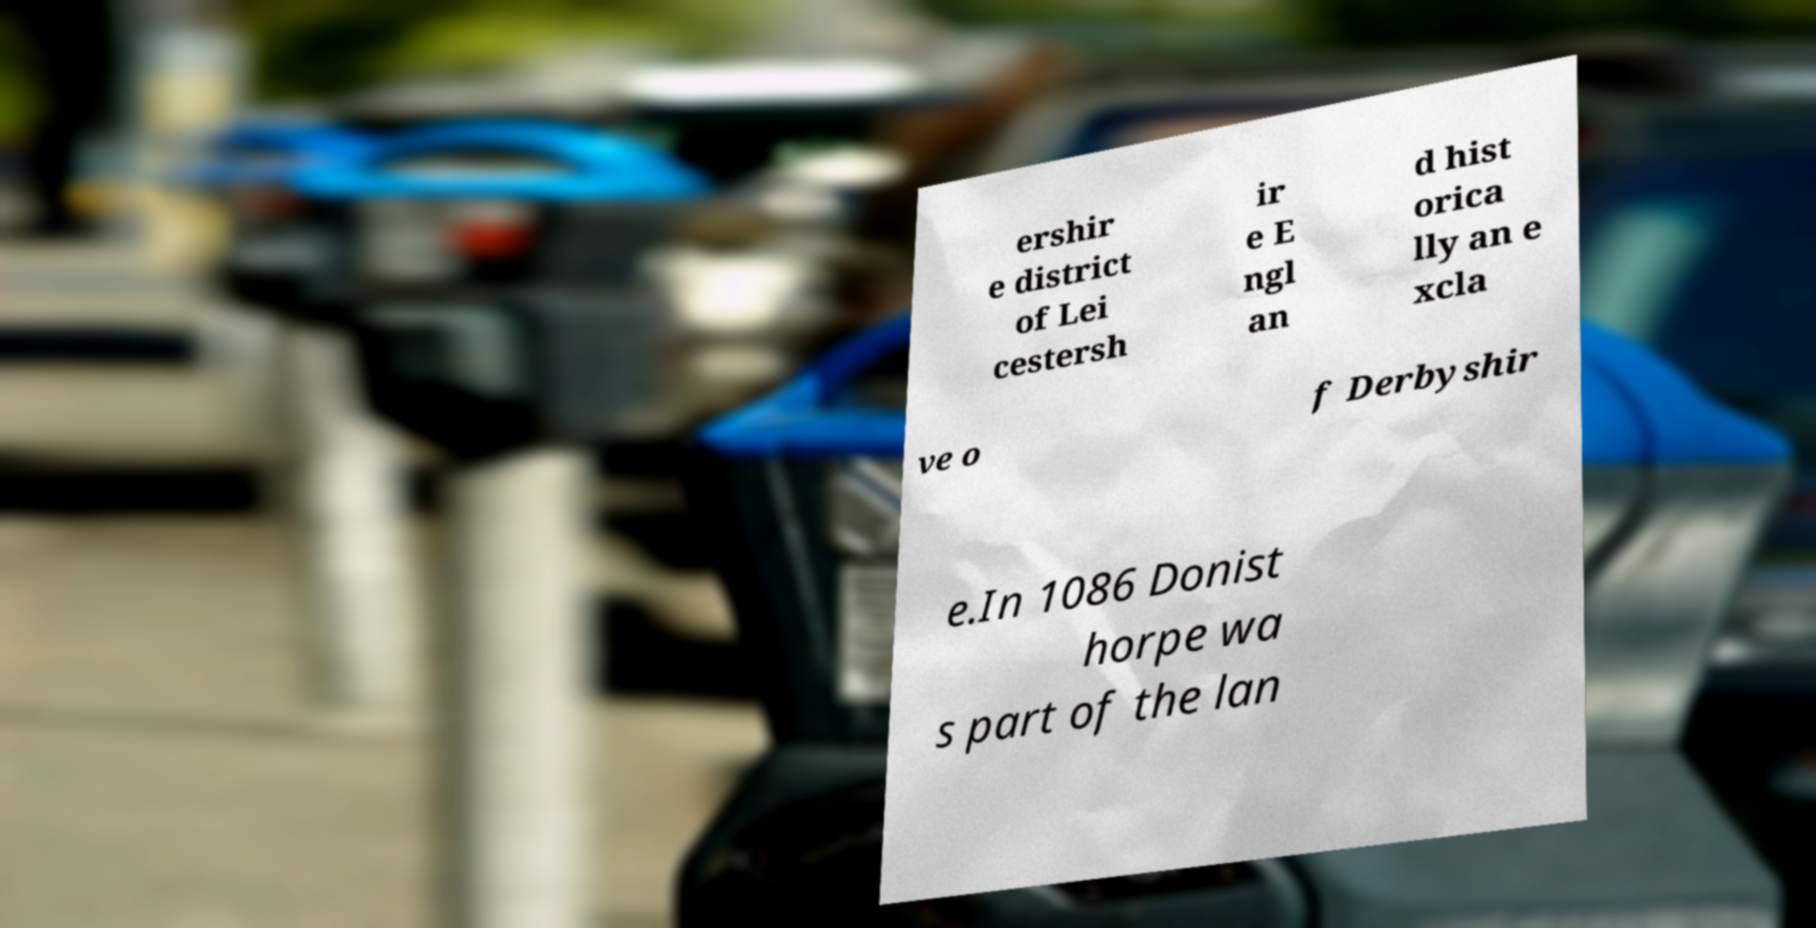Can you read and provide the text displayed in the image?This photo seems to have some interesting text. Can you extract and type it out for me? ershir e district of Lei cestersh ir e E ngl an d hist orica lly an e xcla ve o f Derbyshir e.In 1086 Donist horpe wa s part of the lan 